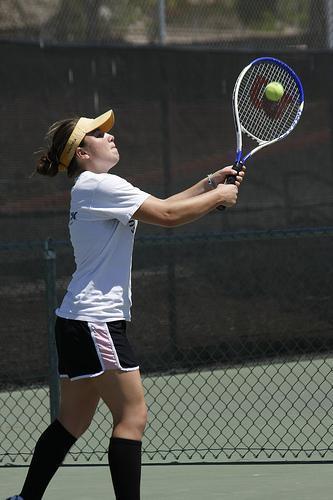How many people in the photo?
Give a very brief answer. 1. 